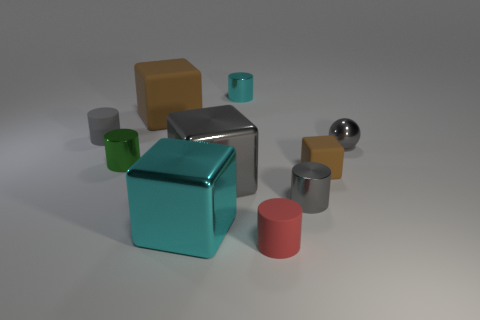What is the lighting situation in this scene? The scene appears to be illuminated by a soft, diffused light source, creating subtle shadows and soft reflections on the objects. The absence of harsh shadows or bright highlights suggests an indoor setting with ambient lighting, likely meant to showcase the objects without overemphasizing their texture or material. 